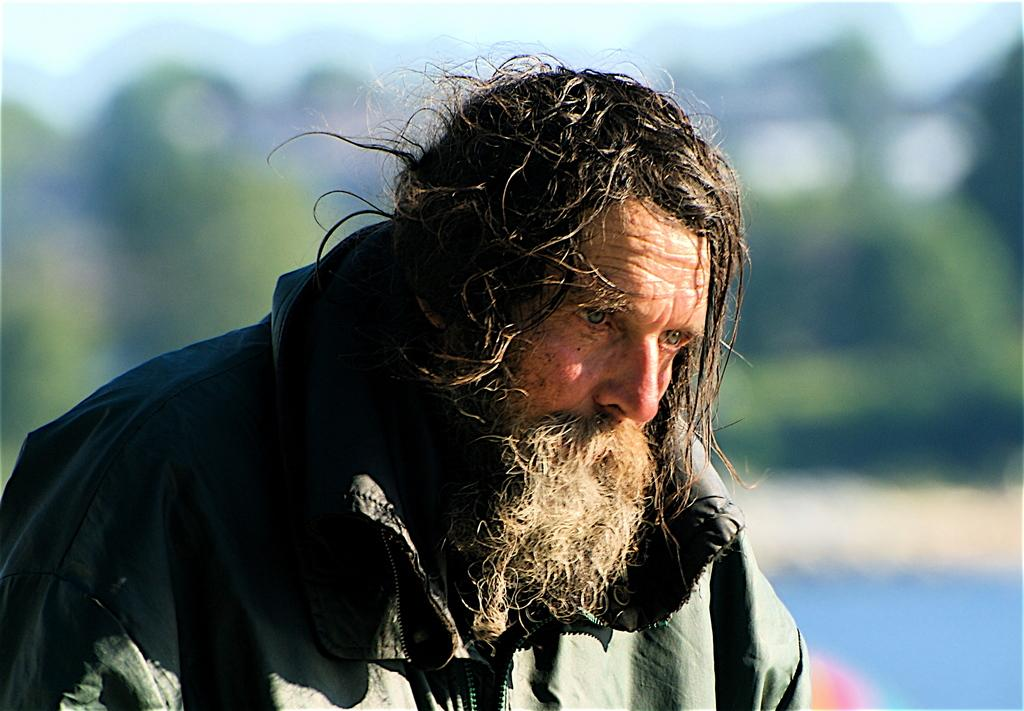Who is present in the image? There is a man in the picture. What is the man wearing? The man is wearing a coat. Can you describe the background of the image? The background of the image is blurry. What type of soda can be seen in the man's hand in the image? There is no soda present in the image; the man is not holding anything in his hand. 